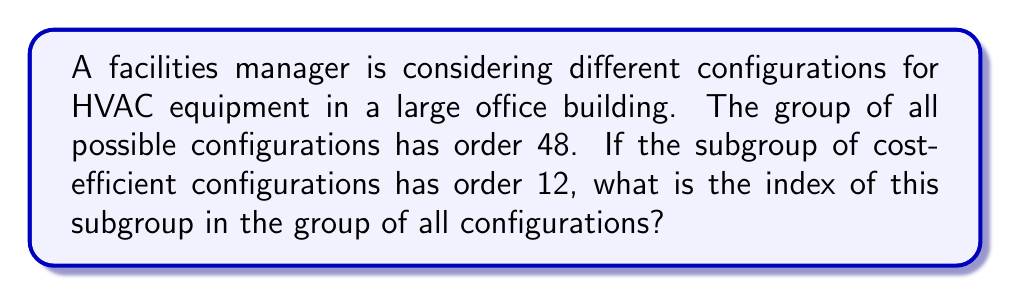Provide a solution to this math problem. Let's approach this step-by-step:

1) First, we need to understand what the index of a subgroup means. The index of a subgroup H in a group G is denoted by [G:H] and is defined as the number of distinct left (or right) cosets of H in G.

2) There's a fundamental theorem in group theory that relates the order of the group, the order of the subgroup, and the index:

   $$|G| = |H| \cdot [G:H]$$

   Where |G| is the order of the group, |H| is the order of the subgroup, and [G:H] is the index of H in G.

3) In this problem, we're given:
   - |G| = 48 (the order of the group of all possible configurations)
   - |H| = 12 (the order of the subgroup of cost-efficient configurations)

4) We can now plug these values into the formula:

   $$48 = 12 \cdot [G:H]$$

5) To solve for [G:H], we divide both sides by 12:

   $$[G:H] = \frac{48}{12} = 4$$

Therefore, the index of the subgroup of cost-efficient configurations in the group of all configurations is 4.
Answer: The index of the subgroup is 4. 